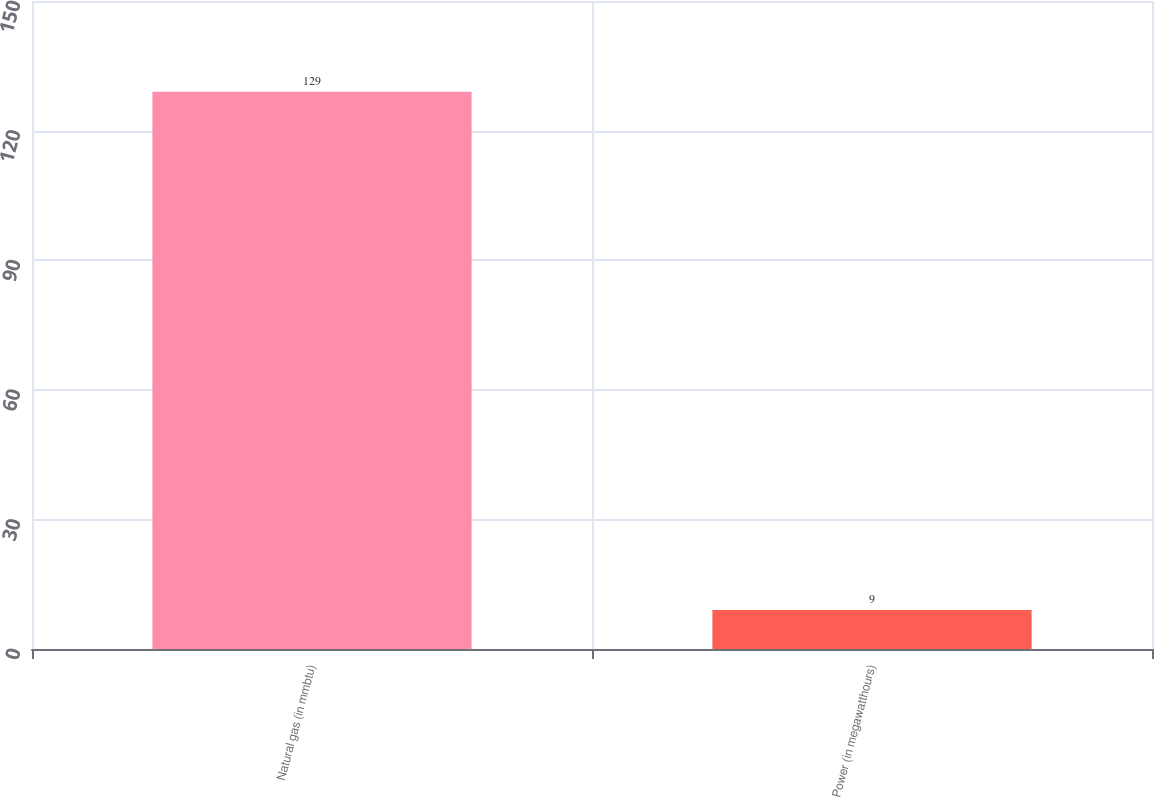Convert chart. <chart><loc_0><loc_0><loc_500><loc_500><bar_chart><fcel>Natural gas (in mmbtu)<fcel>Power (in megawatthours)<nl><fcel>129<fcel>9<nl></chart> 